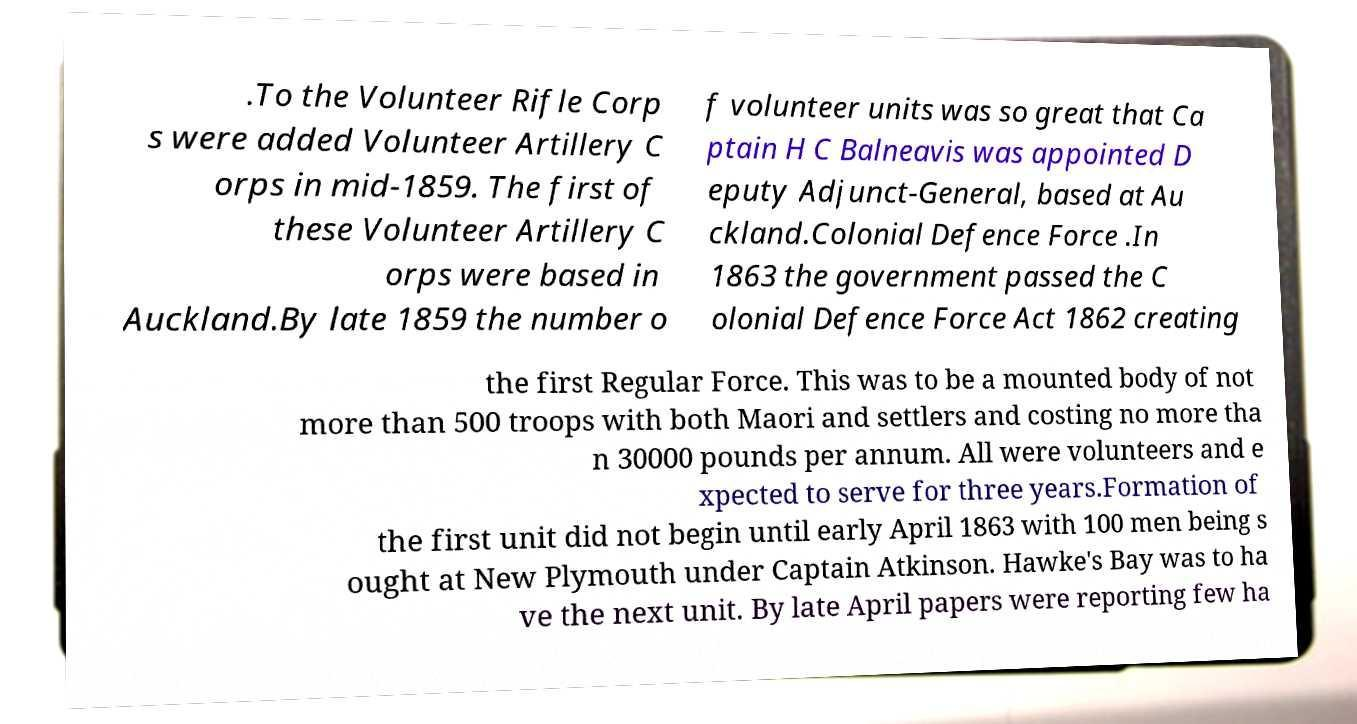There's text embedded in this image that I need extracted. Can you transcribe it verbatim? .To the Volunteer Rifle Corp s were added Volunteer Artillery C orps in mid-1859. The first of these Volunteer Artillery C orps were based in Auckland.By late 1859 the number o f volunteer units was so great that Ca ptain H C Balneavis was appointed D eputy Adjunct-General, based at Au ckland.Colonial Defence Force .In 1863 the government passed the C olonial Defence Force Act 1862 creating the first Regular Force. This was to be a mounted body of not more than 500 troops with both Maori and settlers and costing no more tha n 30000 pounds per annum. All were volunteers and e xpected to serve for three years.Formation of the first unit did not begin until early April 1863 with 100 men being s ought at New Plymouth under Captain Atkinson. Hawke's Bay was to ha ve the next unit. By late April papers were reporting few ha 